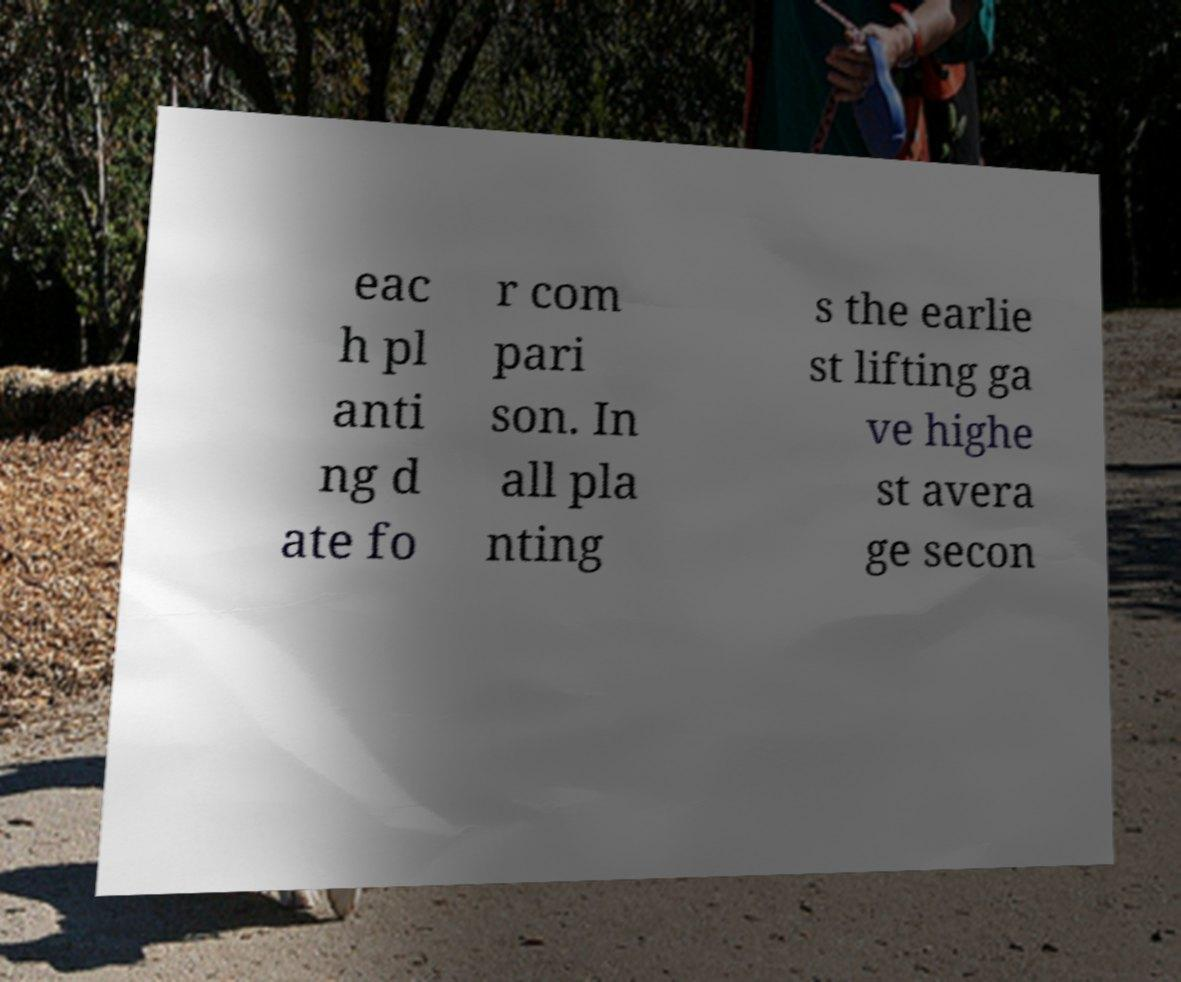There's text embedded in this image that I need extracted. Can you transcribe it verbatim? eac h pl anti ng d ate fo r com pari son. In all pla nting s the earlie st lifting ga ve highe st avera ge secon 